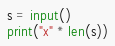<code> <loc_0><loc_0><loc_500><loc_500><_Python_>s = input()
print("x" * len(s))</code> 